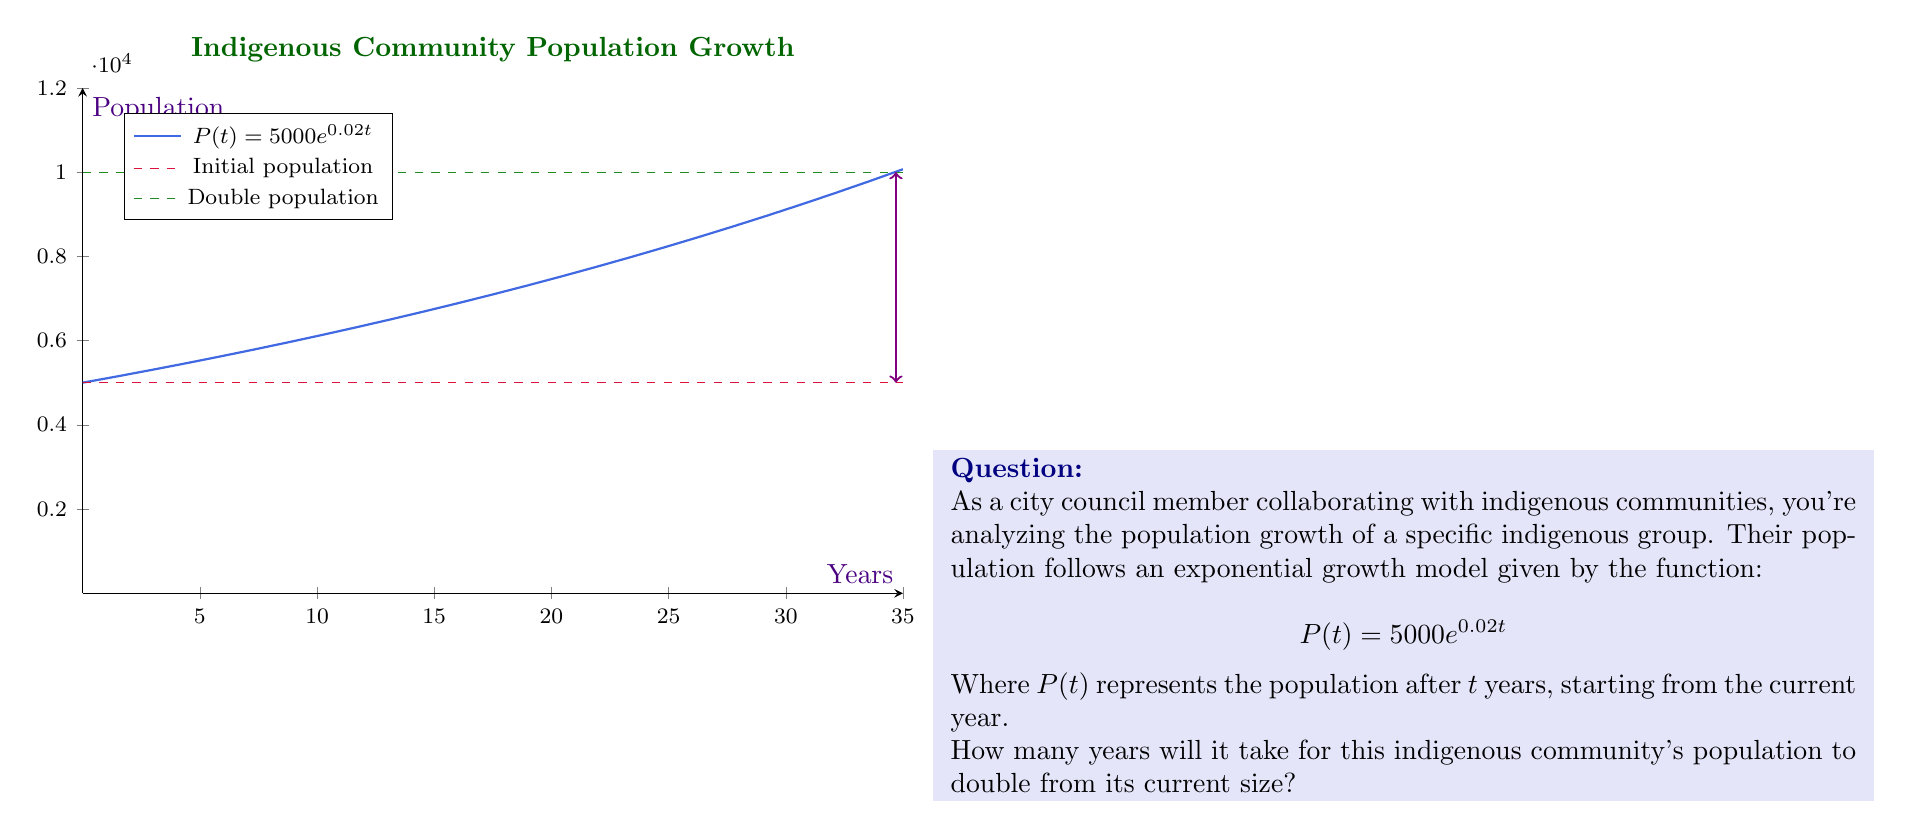Help me with this question. Let's approach this step-by-step:

1) We want to find when the population doubles. This means we're looking for the time $t$ when $P(t) = 2 \cdot 5000 = 10000$.

2) We can set up the equation:
   $$10000 = 5000e^{0.02t}$$

3) Divide both sides by 5000:
   $$2 = e^{0.02t}$$

4) Take the natural logarithm of both sides:
   $$\ln(2) = \ln(e^{0.02t})$$

5) Using the property of logarithms, $\ln(e^x) = x$:
   $$\ln(2) = 0.02t$$

6) Solve for $t$:
   $$t = \frac{\ln(2)}{0.02}$$

7) Calculate:
   $$t = \frac{0.693147...}{0.02} \approx 34.66$$

8) Since we're dealing with years, we round up to the nearest whole year.

Therefore, it will take 35 years for the population to double.
Answer: 35 years 